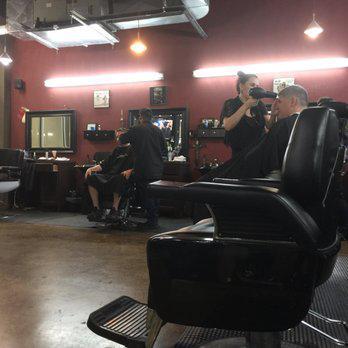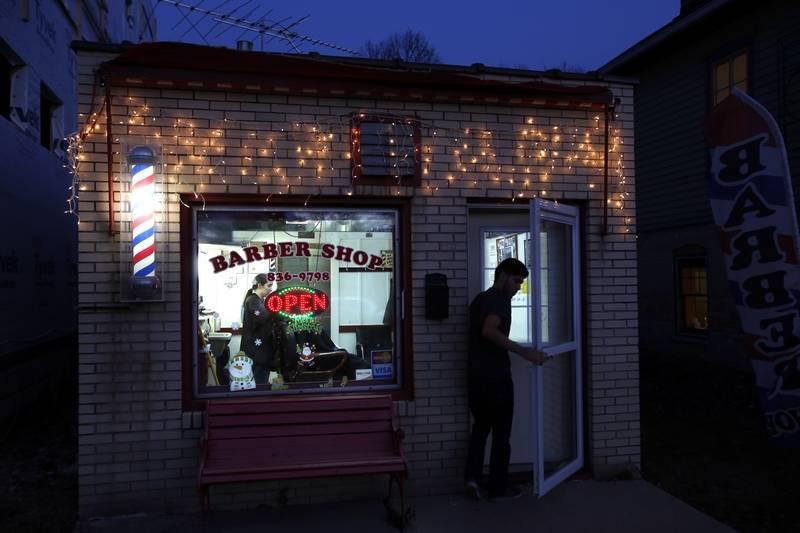The first image is the image on the left, the second image is the image on the right. For the images displayed, is the sentence "There are more than eleven frames on the wall in one of the images." factually correct? Answer yes or no. No. 